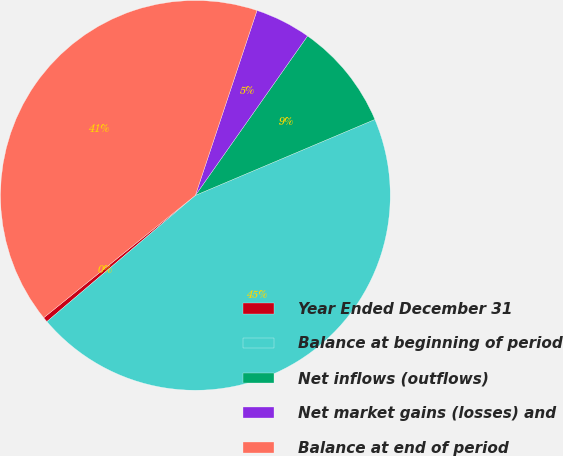Convert chart to OTSL. <chart><loc_0><loc_0><loc_500><loc_500><pie_chart><fcel>Year Ended December 31<fcel>Balance at beginning of period<fcel>Net inflows (outflows)<fcel>Net market gains (losses) and<fcel>Balance at end of period<nl><fcel>0.41%<fcel>45.15%<fcel>8.87%<fcel>4.64%<fcel>40.92%<nl></chart> 